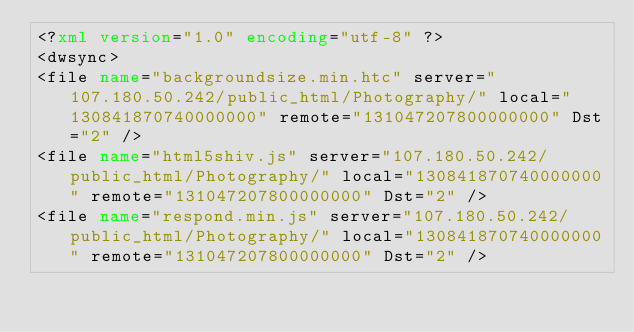Convert code to text. <code><loc_0><loc_0><loc_500><loc_500><_XML_><?xml version="1.0" encoding="utf-8" ?>
<dwsync>
<file name="backgroundsize.min.htc" server="107.180.50.242/public_html/Photography/" local="130841870740000000" remote="131047207800000000" Dst="2" />
<file name="html5shiv.js" server="107.180.50.242/public_html/Photography/" local="130841870740000000" remote="131047207800000000" Dst="2" />
<file name="respond.min.js" server="107.180.50.242/public_html/Photography/" local="130841870740000000" remote="131047207800000000" Dst="2" /></code> 